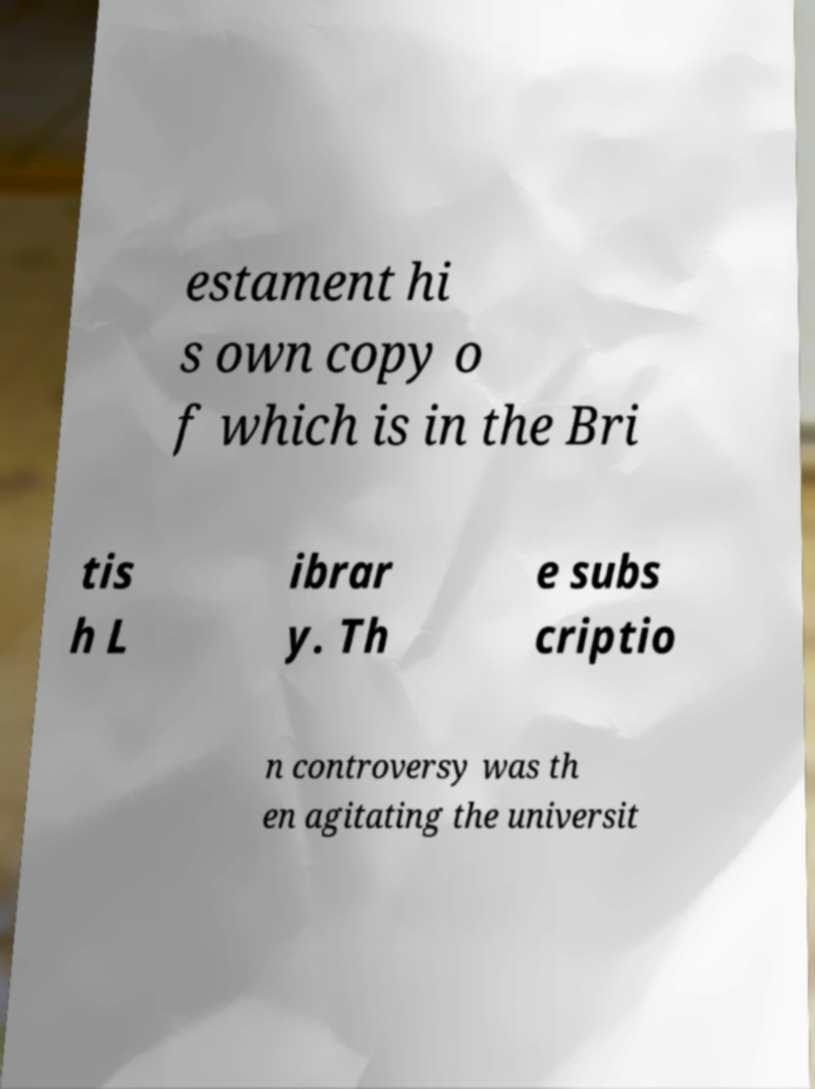For documentation purposes, I need the text within this image transcribed. Could you provide that? estament hi s own copy o f which is in the Bri tis h L ibrar y. Th e subs criptio n controversy was th en agitating the universit 